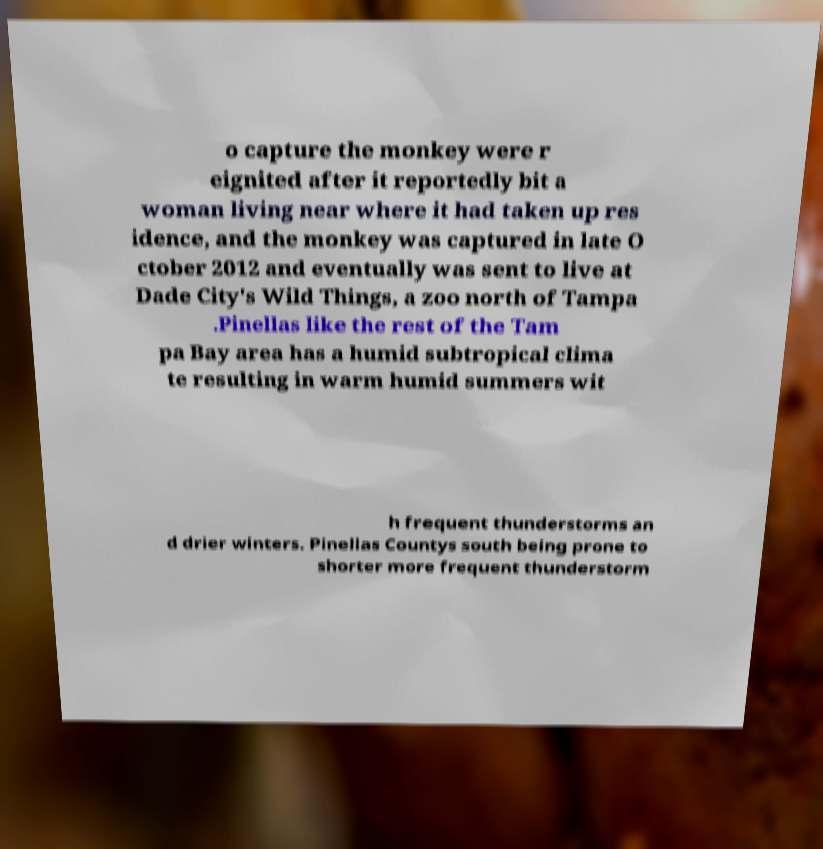Could you extract and type out the text from this image? o capture the monkey were r eignited after it reportedly bit a woman living near where it had taken up res idence, and the monkey was captured in late O ctober 2012 and eventually was sent to live at Dade City's Wild Things, a zoo north of Tampa .Pinellas like the rest of the Tam pa Bay area has a humid subtropical clima te resulting in warm humid summers wit h frequent thunderstorms an d drier winters. Pinellas Countys south being prone to shorter more frequent thunderstorm 